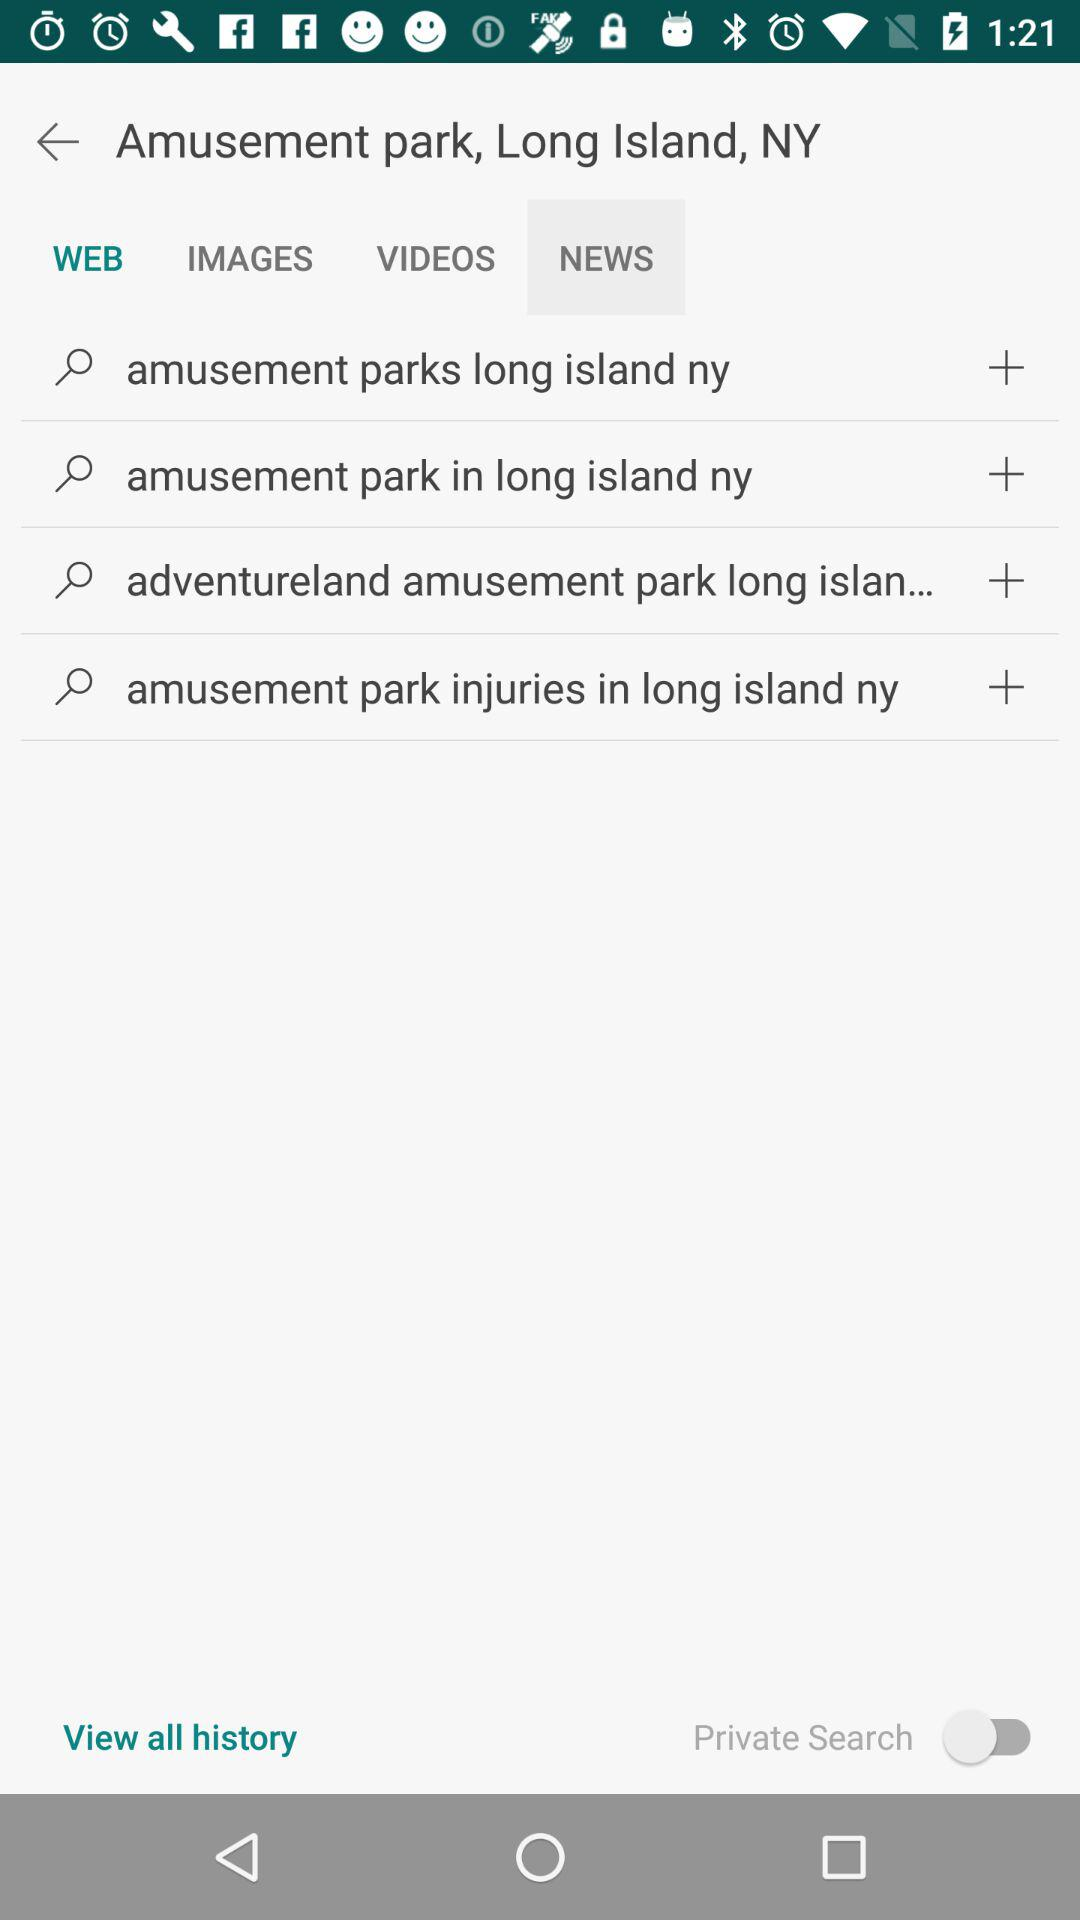What is the person searching for? The person is searching for Amusement park, Long Island, NY. 